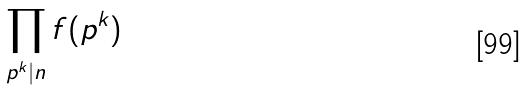<formula> <loc_0><loc_0><loc_500><loc_500>\prod _ { p ^ { k } | n } f ( p ^ { k } )</formula> 